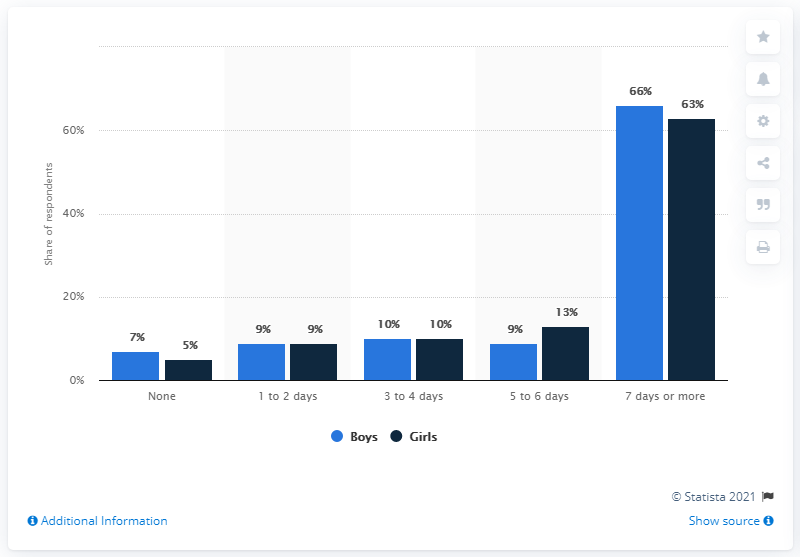Indicate a few pertinent items in this graphic. According to the data, 66% of boys and 63% of girls reported engaging in physical activity for at least an hour every day. According to the data, 66% of boys reported that they were physically active for at least an hour every day. 